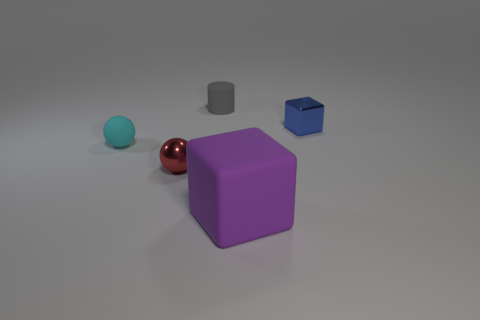What is the material of the ball on the left side of the metallic object that is in front of the tiny cube?
Your answer should be very brief. Rubber. There is a blue metallic block behind the tiny cyan matte thing; what size is it?
Provide a succinct answer. Small. How many green things are either tiny balls or tiny metallic cylinders?
Give a very brief answer. 0. Is there any other thing that has the same material as the small blue cube?
Give a very brief answer. Yes. There is a cyan thing that is the same shape as the small red shiny thing; what is it made of?
Give a very brief answer. Rubber. Are there the same number of large cubes that are on the right side of the tiny cube and metallic blocks?
Keep it short and to the point. No. There is a matte thing that is in front of the tiny gray matte cylinder and behind the tiny red metallic ball; what size is it?
Offer a terse response. Small. Are there any other things that are the same color as the shiny block?
Your response must be concise. No. How big is the rubber thing left of the small shiny thing that is to the left of the big purple object?
Provide a short and direct response. Small. The matte object that is right of the cyan thing and in front of the gray object is what color?
Your response must be concise. Purple. 